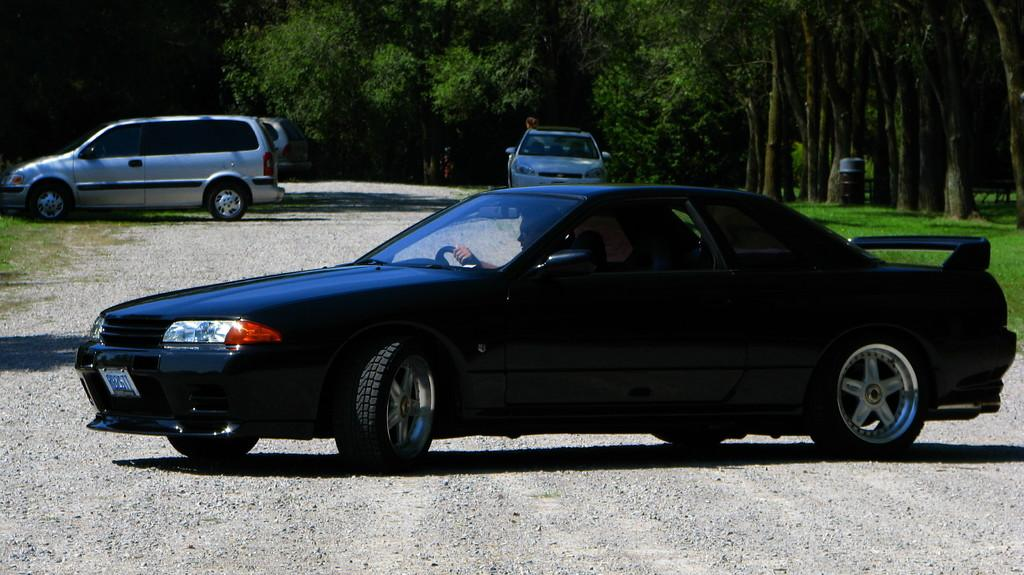What is the main subject of the image? The main subject of the image is a car. Can you describe the car in the image? The car is black in color and is located in the center of the image. What is happening inside the car? There are persons sitting inside the car. What can be seen in the background of the image? There are cars and trees in the background of the image. What type of ground surface is visible in the image? There is grass on the ground in the image. How many jellyfish can be seen swimming in the grass in the image? There are no jellyfish present in the image, and jellyfish cannot swim in grass. What type of account is being discussed by the persons sitting inside the car? There is no information about any accounts being discussed by the persons sitting inside the car. 